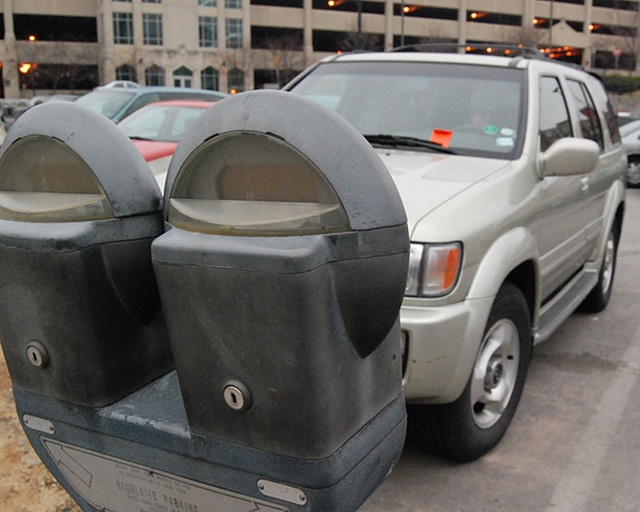Describe the objects in this image and their specific colors. I can see car in gray, darkgray, lightgray, and black tones, parking meter in gray, black, and darkgray tones, parking meter in gray, black, and darkgray tones, car in gray, darkgray, lightpink, and lightgray tones, and car in gray, darkgray, and lightgray tones in this image. 